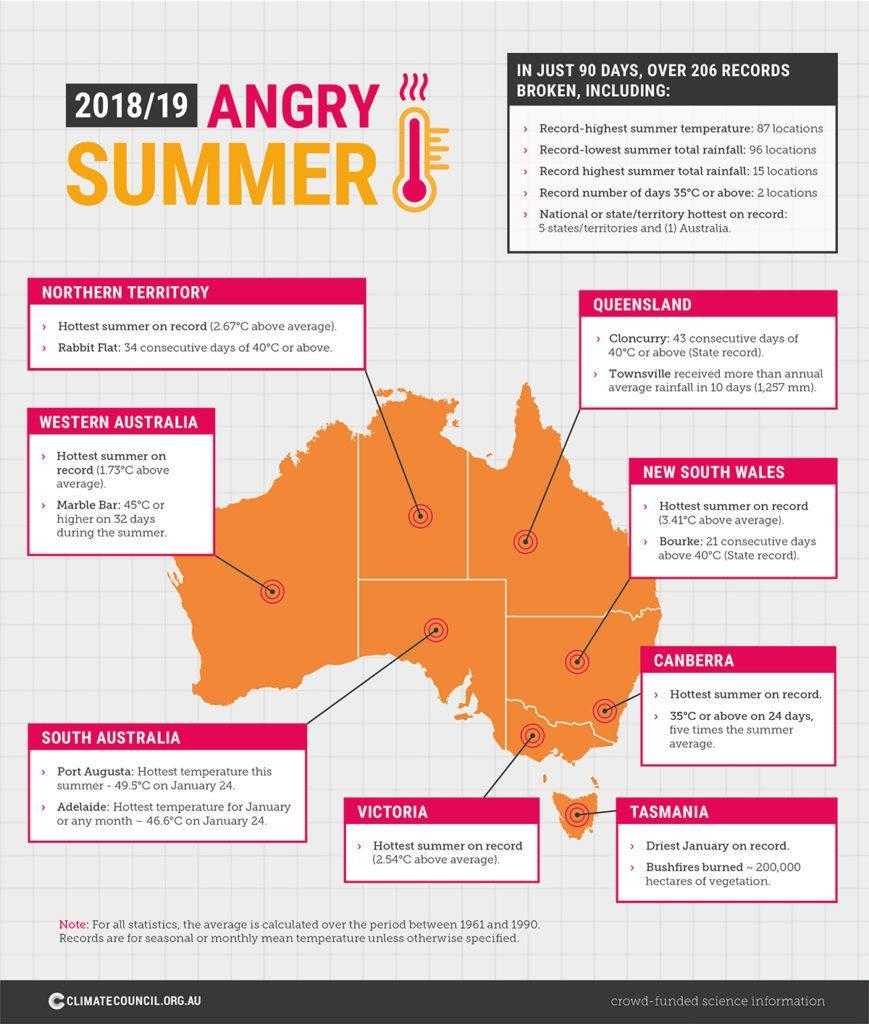where was the summer 3.41 above average
Answer the question with a short phrase. new south wales where was hottest summer 2.54 above average victoria which place had the driest January tasmania where was the summer 1.75 above average western australia what colour is the map of australia, pink or orange orange 